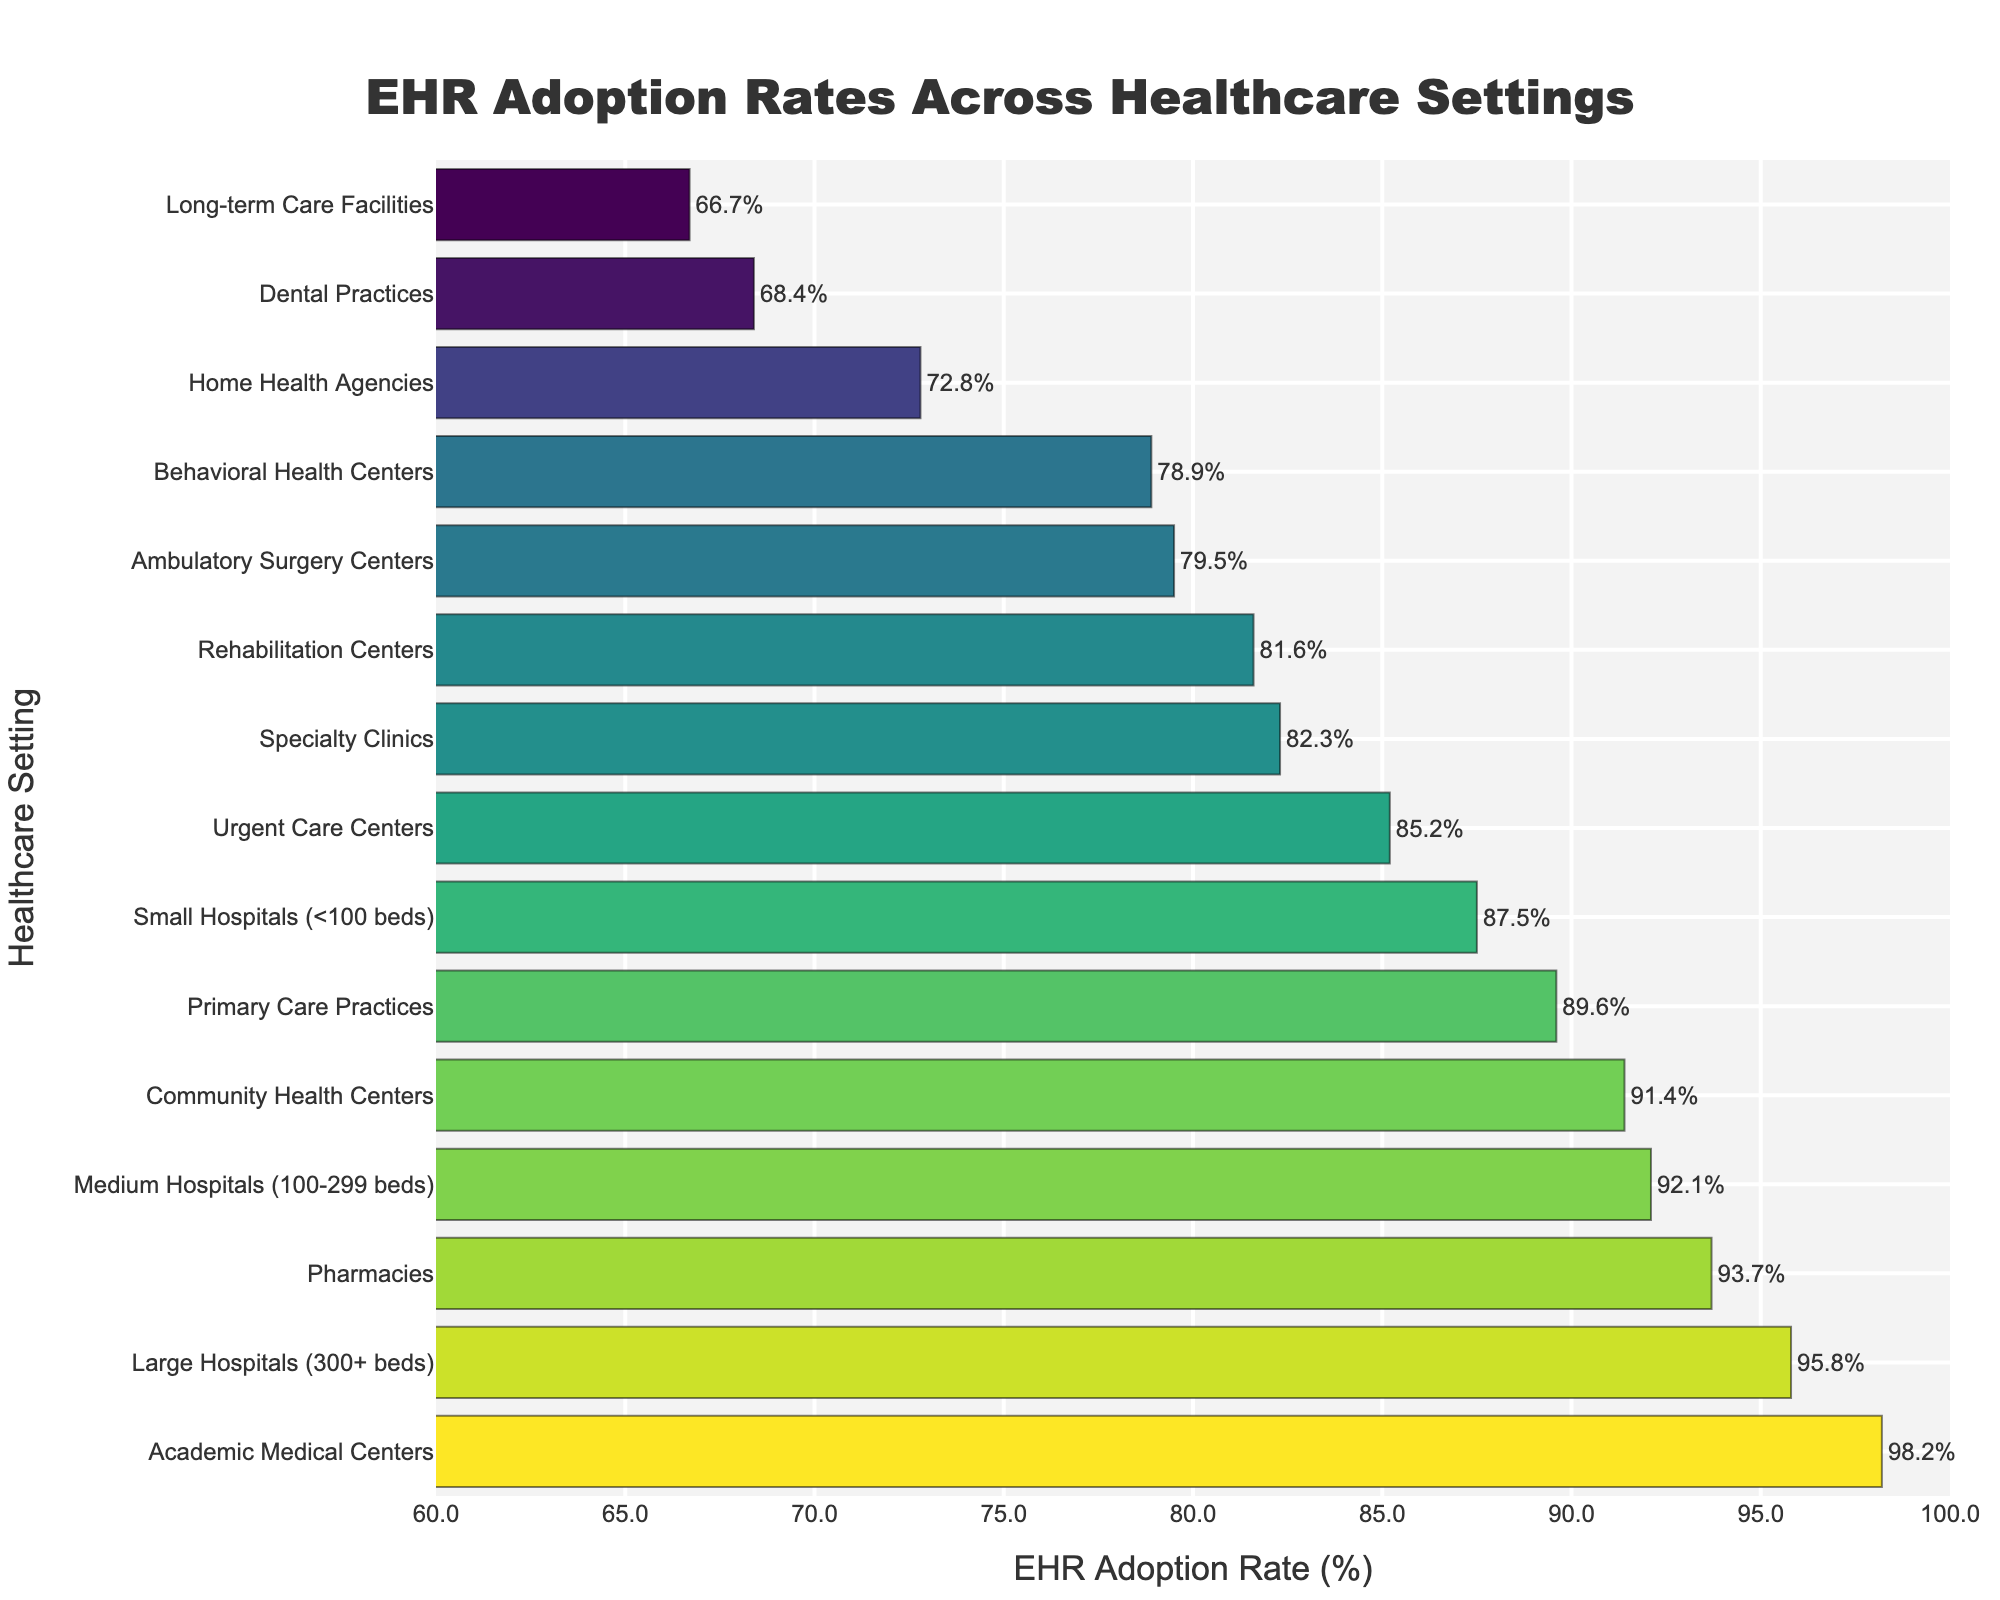Which healthcare setting has the highest EHR adoption rate? The highest bar on the chart corresponds to 'Academic Medical Centers,' which has an EHR adoption rate of 98.2%.
Answer: Academic Medical Centers What's the EHR adoption rate for specialty clinics? Locate the bar labeled 'Specialty Clinics' on the y-axis. The length of the bar shows an EHR adoption rate of 82.3%.
Answer: 82.3% Which has a higher EHR adoption rate: small hospitals or community health centers? Compare the lengths of the bars for 'Small Hospitals' and 'Community Health Centers.' 'Small Hospitals' have an adoption rate of 87.5%, while 'Community Health Centers' have an adoption rate of 91.4%. Therefore, 'Community Health Centers' have a higher rate.
Answer: Community Health Centers What is the average EHR adoption rate for large hospitals, medium hospitals, and small hospitals? Add the EHR adoption rates for large hospitals (95.8), medium hospitals (92.1), and small hospitals (87.5), then divide by 3 to get the average. (95.8 + 92.1 + 87.5) / 3 = 91.8%
Answer: 91.8% Are there any healthcare settings with an EHR adoption rate below 70%? Check the bars to find any adoption rates below the 70% mark. 'Long-term Care Facilities' (66.7%) and 'Dental Practices' (68.4%) have rates below 70%.
Answer: Yes What is the combined EHR adoption rate for primary care practices and behavioral health centers? Add the EHR adoption rates for 'Primary Care Practices' (89.6%) and 'Behavioral Health Centers' (78.9%). 89.6 + 78.9 = 168.5%
Answer: 168.5% Which healthcare setting has the third-highest EHR adoption rate? Identify the bars in descending order and find the third one. The third-highest is 'Pharmacies' with a 93.7% adoption rate.
Answer: Pharmacies What's the difference in EHR adoption rates between urgent care centers and home health agencies? Subtract the EHR adoption rate of 'Home Health Agencies' (72.8%) from 'Urgent Care Centers' (85.2%). 85.2 - 72.8 = 12.4%
Answer: 12.4% How many healthcare settings have an EHR adoption rate greater than 90%? Count the bars with adoption rates above the 90% mark. They are 'Large Hospitals,' 'Medium Hospitals,' 'Academic Medical Centers,' 'Community Health Centers,' and 'Pharmacies', making a total of 5.
Answer: 5 What is the range of EHR adoption rates shown in the chart? Subtract the smallest EHR adoption rate (66.7% for Long-term Care Facilities) from the largest (98.2% for Academic Medical Centers). 98.2 - 66.7 = 31.5%
Answer: 31.5% 